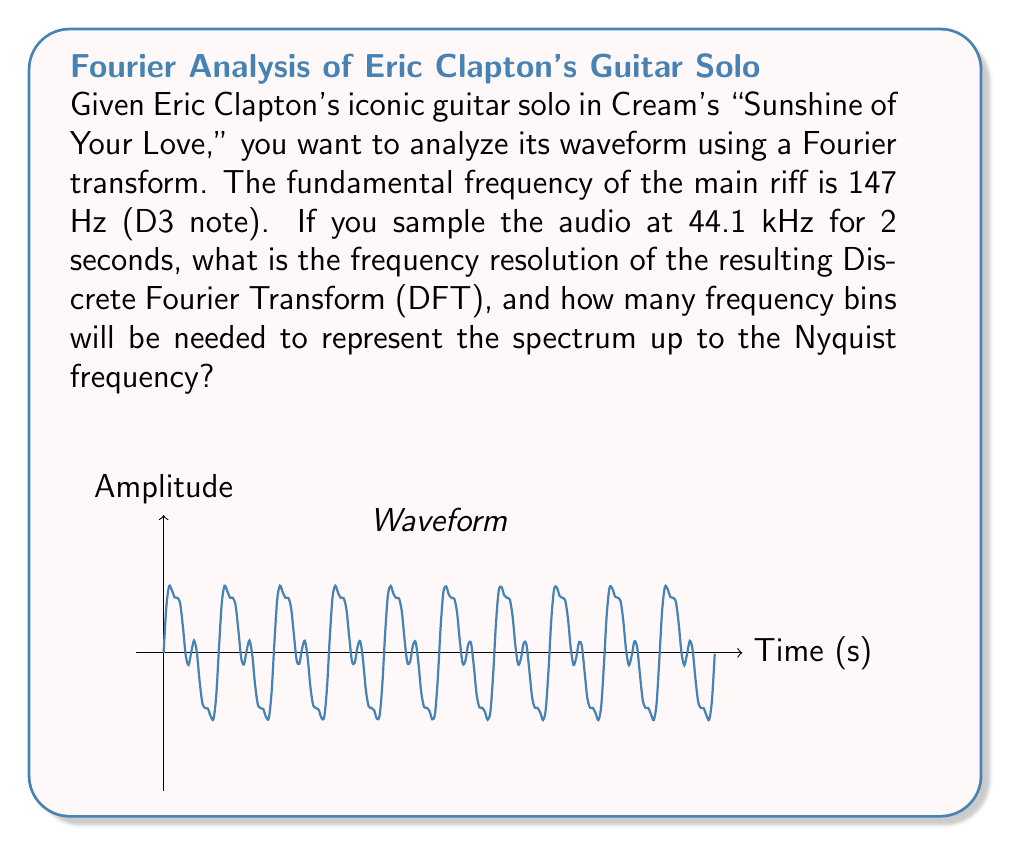Help me with this question. Let's approach this step-by-step:

1) First, we need to understand the relationship between sampling rate, duration, and frequency resolution in the DFT:

   Frequency Resolution, $\Delta f = \frac{f_s}{N}$

   Where $f_s$ is the sampling rate and $N$ is the number of samples.

2) We're given:
   - Sampling rate, $f_s = 44.1$ kHz = 44100 Hz
   - Duration, $T = 2$ seconds

3) Calculate the number of samples, $N$:
   $N = f_s \times T = 44100 \times 2 = 88200$ samples

4) Now we can calculate the frequency resolution:

   $\Delta f = \frac{f_s}{N} = \frac{44100}{88200} = 0.5$ Hz

5) For the number of frequency bins, we need to consider the Nyquist frequency, which is half the sampling rate:

   Nyquist frequency = $\frac{f_s}{2} = \frac{44100}{2} = 22050$ Hz

6) The number of frequency bins up to the Nyquist frequency will be:

   Number of bins = $\frac{\text{Nyquist frequency}}{\Delta f} = \frac{22050}{0.5} = 44100$

This means we'll have frequency bins from 0 Hz to 22050 Hz, with a resolution of 0.5 Hz between each bin.
Answer: Frequency resolution: 0.5 Hz; Number of bins: 44100 